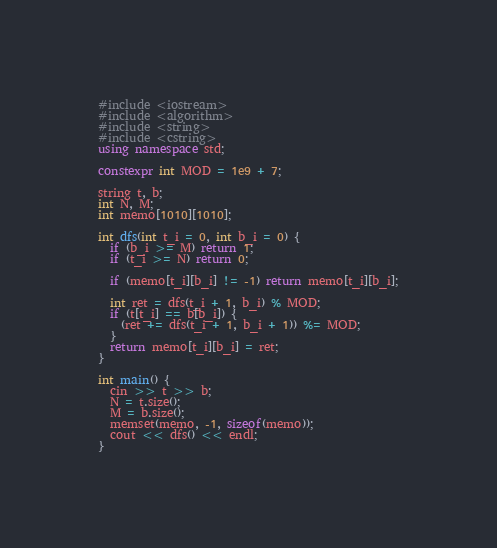Convert code to text. <code><loc_0><loc_0><loc_500><loc_500><_C++_>#include <iostream>
#include <algorithm>
#include <string>
#include <cstring>
using namespace std;

constexpr int MOD = 1e9 + 7;

string t, b;
int N, M;
int memo[1010][1010];

int dfs(int t_i = 0, int b_i = 0) {
  if (b_i >= M) return 1;
  if (t_i >= N) return 0;

  if (memo[t_i][b_i] != -1) return memo[t_i][b_i];

  int ret = dfs(t_i + 1, b_i) % MOD;
  if (t[t_i] == b[b_i]) {
    (ret += dfs(t_i + 1, b_i + 1)) %= MOD;
  }
  return memo[t_i][b_i] = ret;
}

int main() {
  cin >> t >> b;
  N = t.size();
  M = b.size();
  memset(memo, -1, sizeof(memo));
  cout << dfs() << endl;
}</code> 